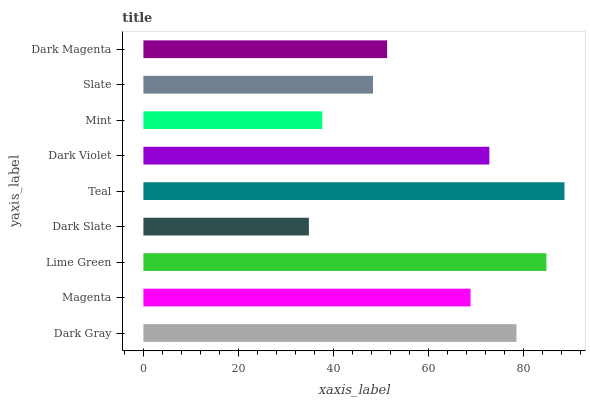Is Dark Slate the minimum?
Answer yes or no. Yes. Is Teal the maximum?
Answer yes or no. Yes. Is Magenta the minimum?
Answer yes or no. No. Is Magenta the maximum?
Answer yes or no. No. Is Dark Gray greater than Magenta?
Answer yes or no. Yes. Is Magenta less than Dark Gray?
Answer yes or no. Yes. Is Magenta greater than Dark Gray?
Answer yes or no. No. Is Dark Gray less than Magenta?
Answer yes or no. No. Is Magenta the high median?
Answer yes or no. Yes. Is Magenta the low median?
Answer yes or no. Yes. Is Lime Green the high median?
Answer yes or no. No. Is Slate the low median?
Answer yes or no. No. 